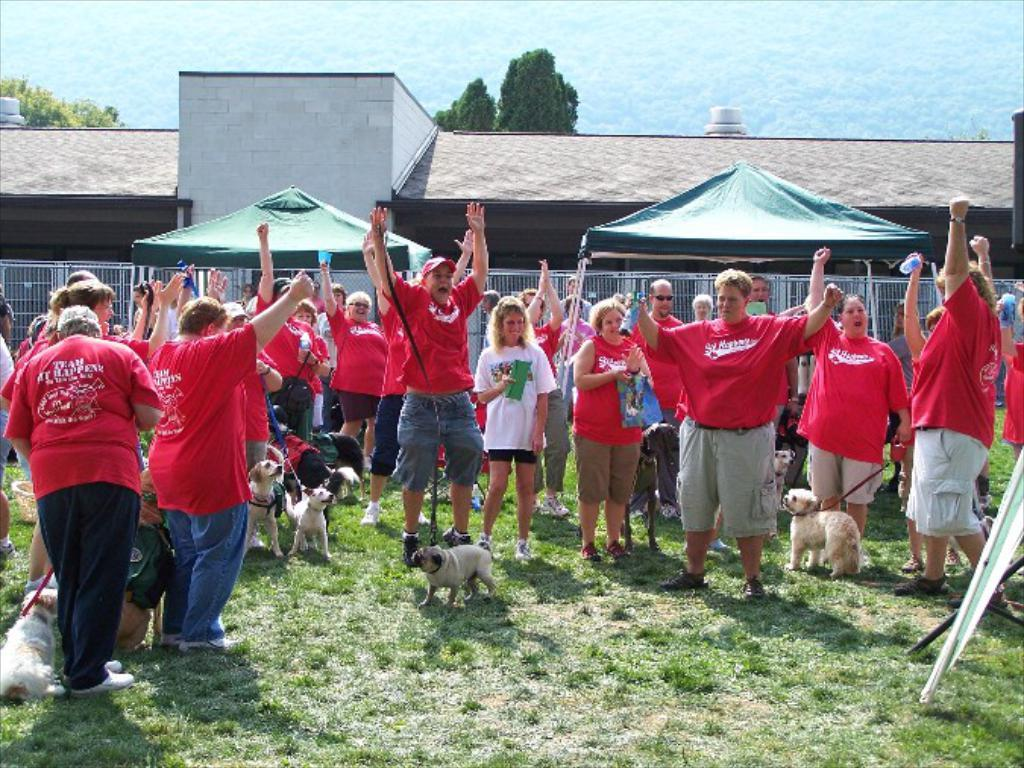What is the main subject of the image? The main subject of the image is a group of persons. What are the persons wearing? The persons are wearing red shirts. What are the persons holding in their hands? The persons are holding belts in their hands. What are the belts attached to? The belts are attached to dogs. What can be seen in the background of the image? There is a building in the background of the image. What type of haircut is the clock getting in the image? There is no clock present in the image, and therefore no haircut can be observed. What property is being discussed by the persons in the image? There is no discussion about a property in the image; the persons are holding belts attached to dogs. 